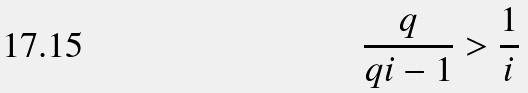<formula> <loc_0><loc_0><loc_500><loc_500>\frac { q } { q i - 1 } > \frac { 1 } { i }</formula> 